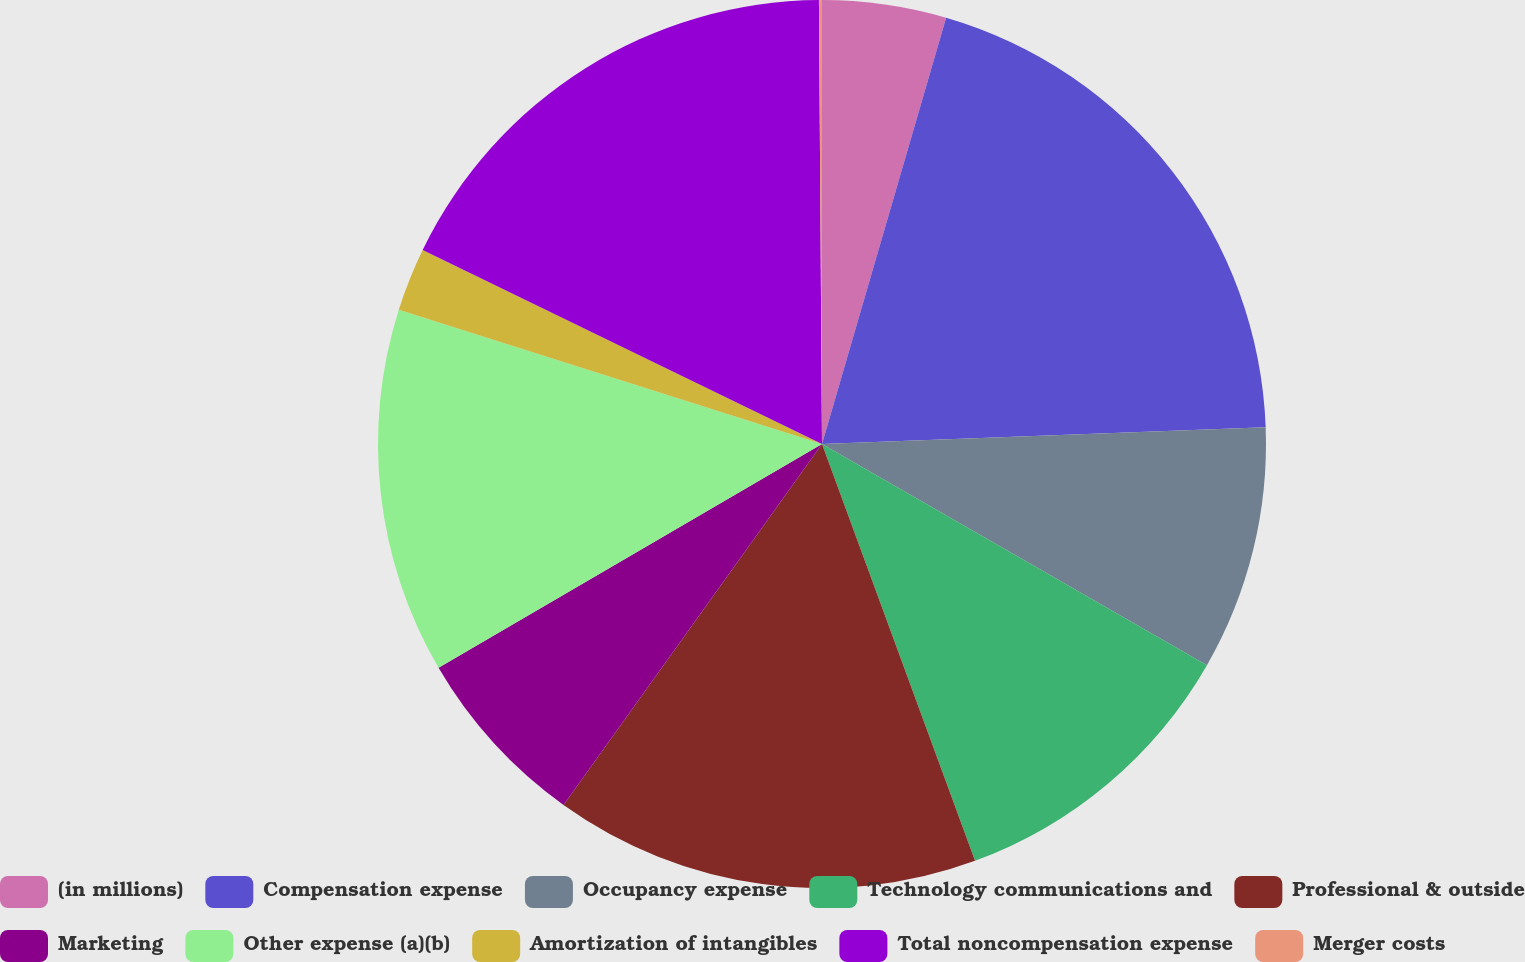Convert chart. <chart><loc_0><loc_0><loc_500><loc_500><pie_chart><fcel>(in millions)<fcel>Compensation expense<fcel>Occupancy expense<fcel>Technology communications and<fcel>Professional & outside<fcel>Marketing<fcel>Other expense (a)(b)<fcel>Amortization of intangibles<fcel>Total noncompensation expense<fcel>Merger costs<nl><fcel>4.51%<fcel>19.89%<fcel>8.9%<fcel>11.1%<fcel>15.49%<fcel>6.7%<fcel>13.3%<fcel>2.31%<fcel>17.69%<fcel>0.11%<nl></chart> 